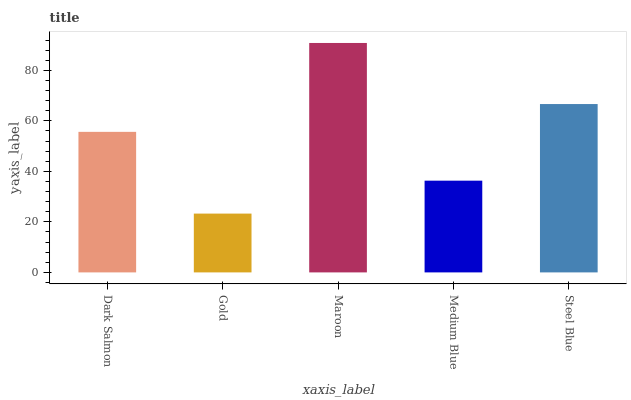Is Gold the minimum?
Answer yes or no. Yes. Is Maroon the maximum?
Answer yes or no. Yes. Is Maroon the minimum?
Answer yes or no. No. Is Gold the maximum?
Answer yes or no. No. Is Maroon greater than Gold?
Answer yes or no. Yes. Is Gold less than Maroon?
Answer yes or no. Yes. Is Gold greater than Maroon?
Answer yes or no. No. Is Maroon less than Gold?
Answer yes or no. No. Is Dark Salmon the high median?
Answer yes or no. Yes. Is Dark Salmon the low median?
Answer yes or no. Yes. Is Maroon the high median?
Answer yes or no. No. Is Maroon the low median?
Answer yes or no. No. 